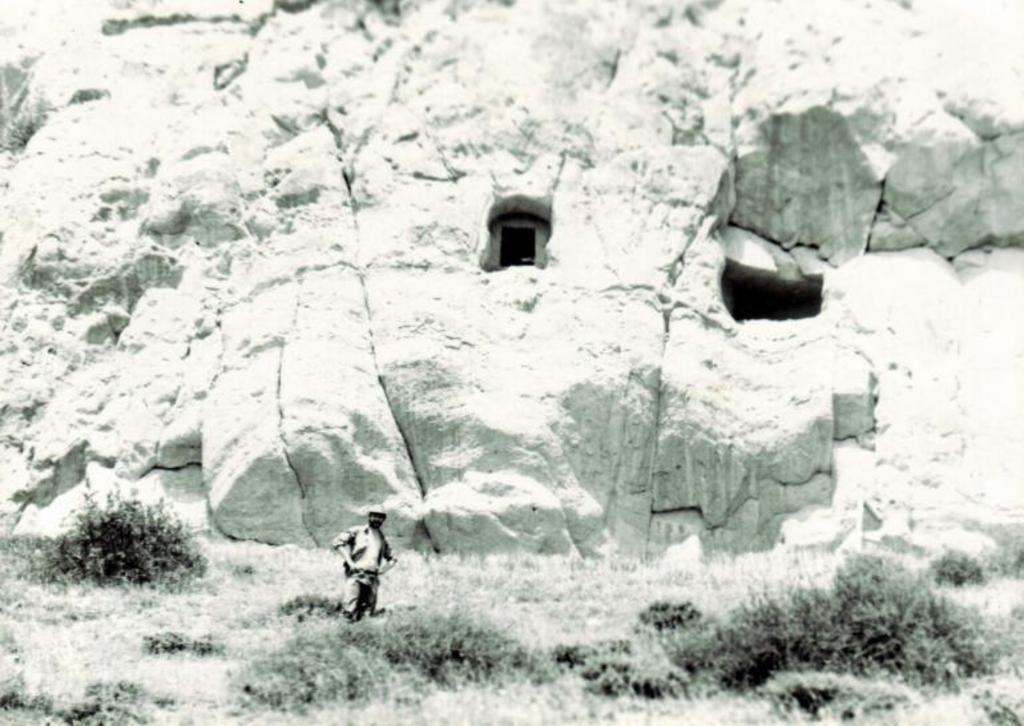Can you describe this image briefly? In the image there is a person standing in between the grass and behind him there is a huge hill. 